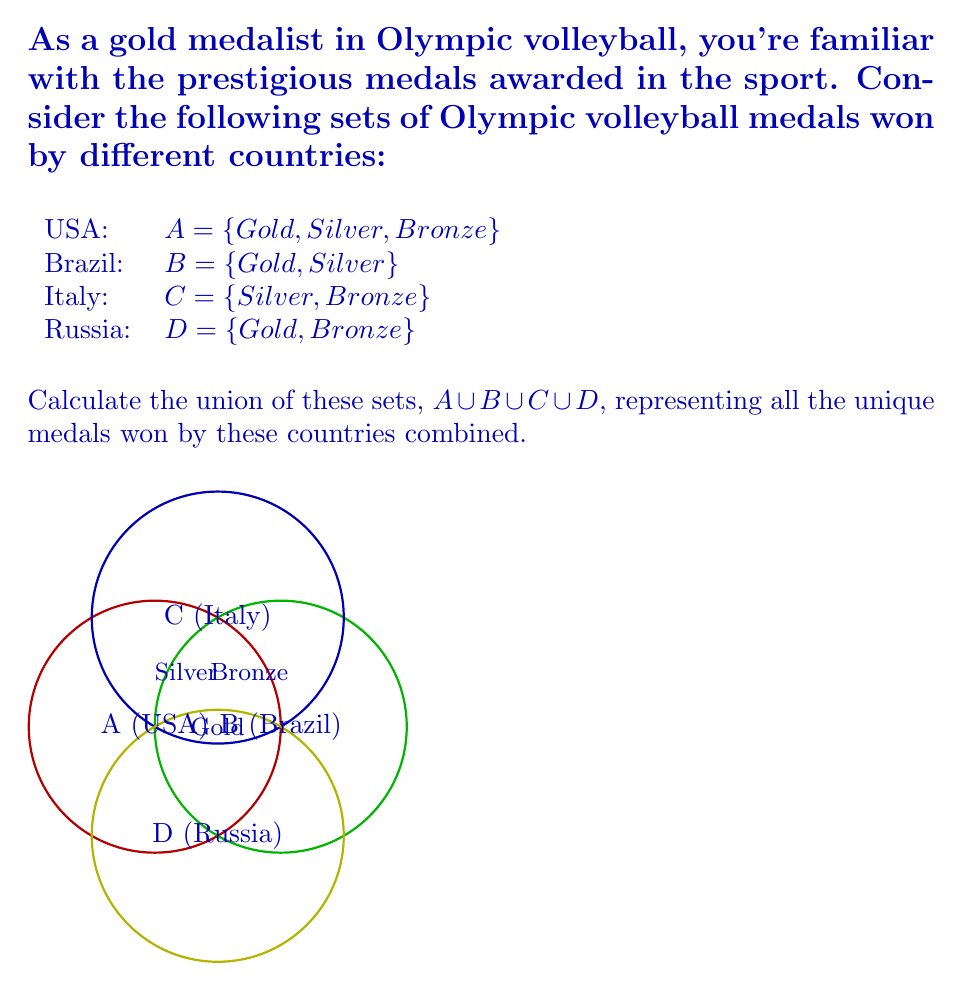Help me with this question. To calculate the union of these sets, we need to identify all unique elements across all sets. Let's approach this step-by-step:

1) First, list out all elements in each set:
   $A = \{Gold, Silver, Bronze\}$
   $B = \{Gold, Silver\}$
   $C = \{Silver, Bronze\}$
   $D = \{Gold, Bronze\}$

2) The union of these sets will include all unique elements that appear in any of the sets.

3) Identifying unique elements:
   - Gold appears in A, B, and D
   - Silver appears in A, B, and C
   - Bronze appears in A, C, and D

4) Therefore, the union $A \cup B \cup C \cup D$ contains all three medal types:
   $A \cup B \cup C \cup D = \{Gold, Silver, Bronze\}$

5) Mathematically, we can express this as:
   $$A \cup B \cup C \cup D = \{x | x \in A \lor x \in B \lor x \in C \lor x \in D\}$$

   Where $\lor$ represents the logical "OR" operation.

The result shows that among these four countries, all three types of Olympic medals have been won in volleyball.
Answer: $\{Gold, Silver, Bronze\}$ 